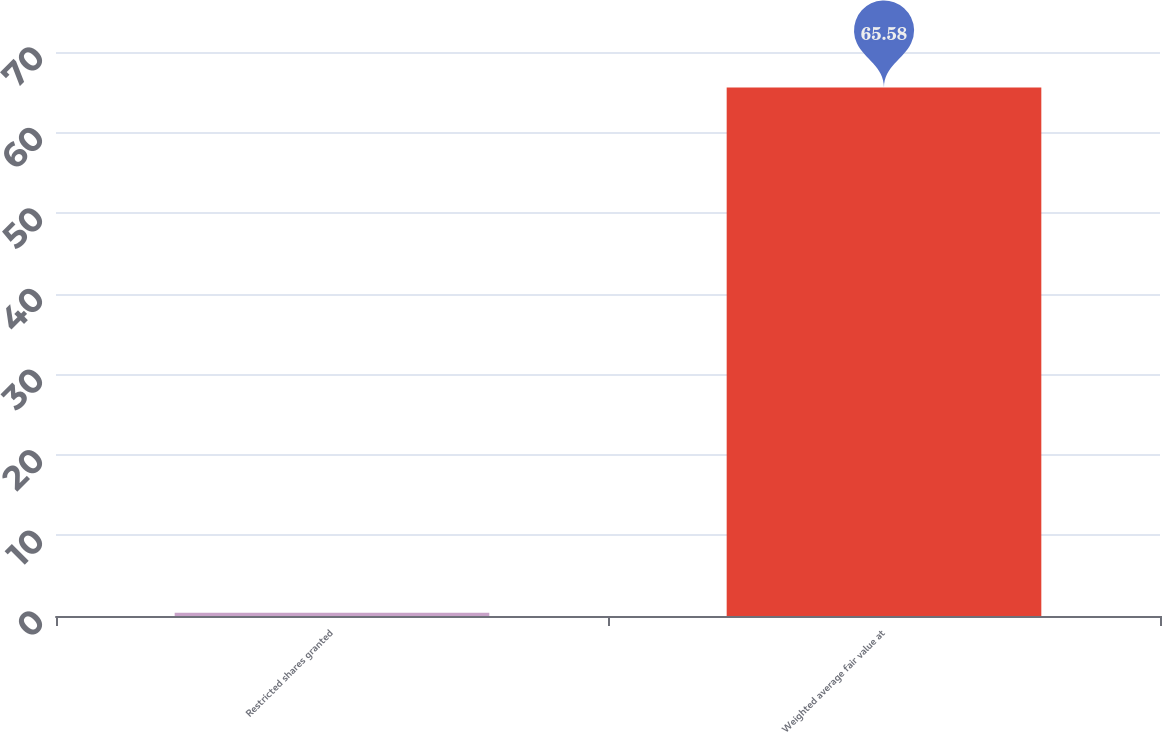Convert chart. <chart><loc_0><loc_0><loc_500><loc_500><bar_chart><fcel>Restricted shares granted<fcel>Weighted average fair value at<nl><fcel>0.4<fcel>65.58<nl></chart> 